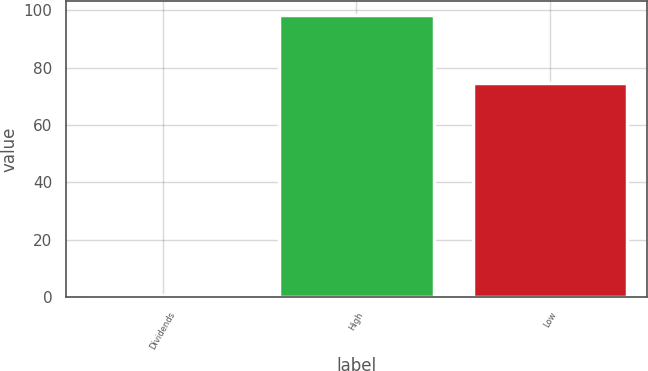<chart> <loc_0><loc_0><loc_500><loc_500><bar_chart><fcel>Dividends<fcel>High<fcel>Low<nl><fcel>0.55<fcel>98.28<fcel>74.78<nl></chart> 